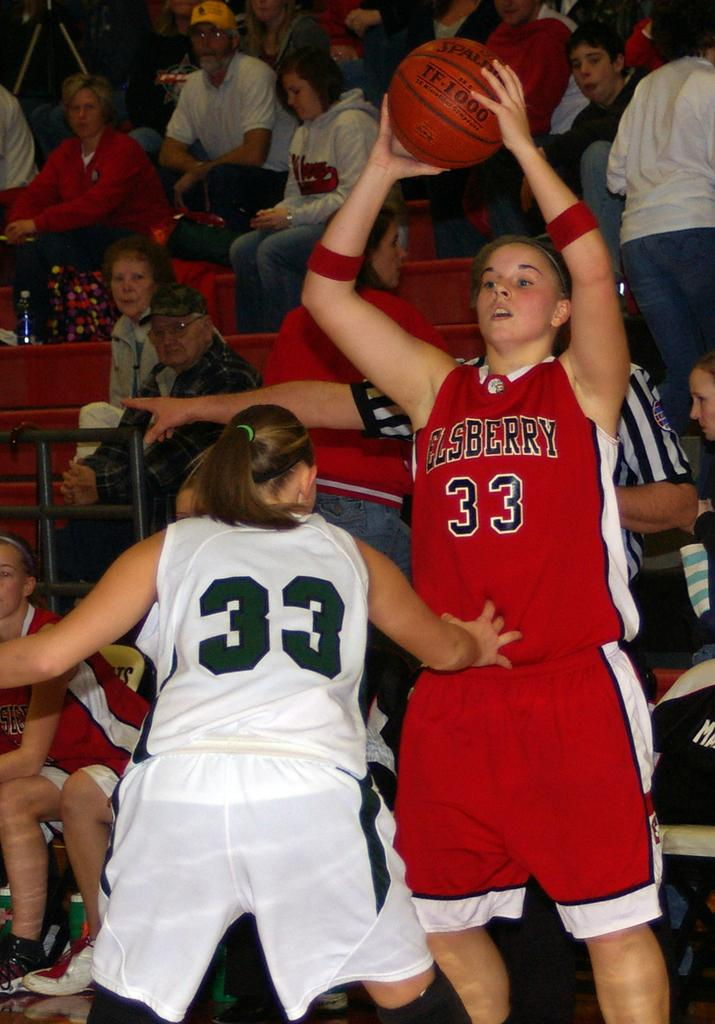<image>
Offer a succinct explanation of the picture presented. Two girls playing basket ball with the number 33 on their uniforms. 